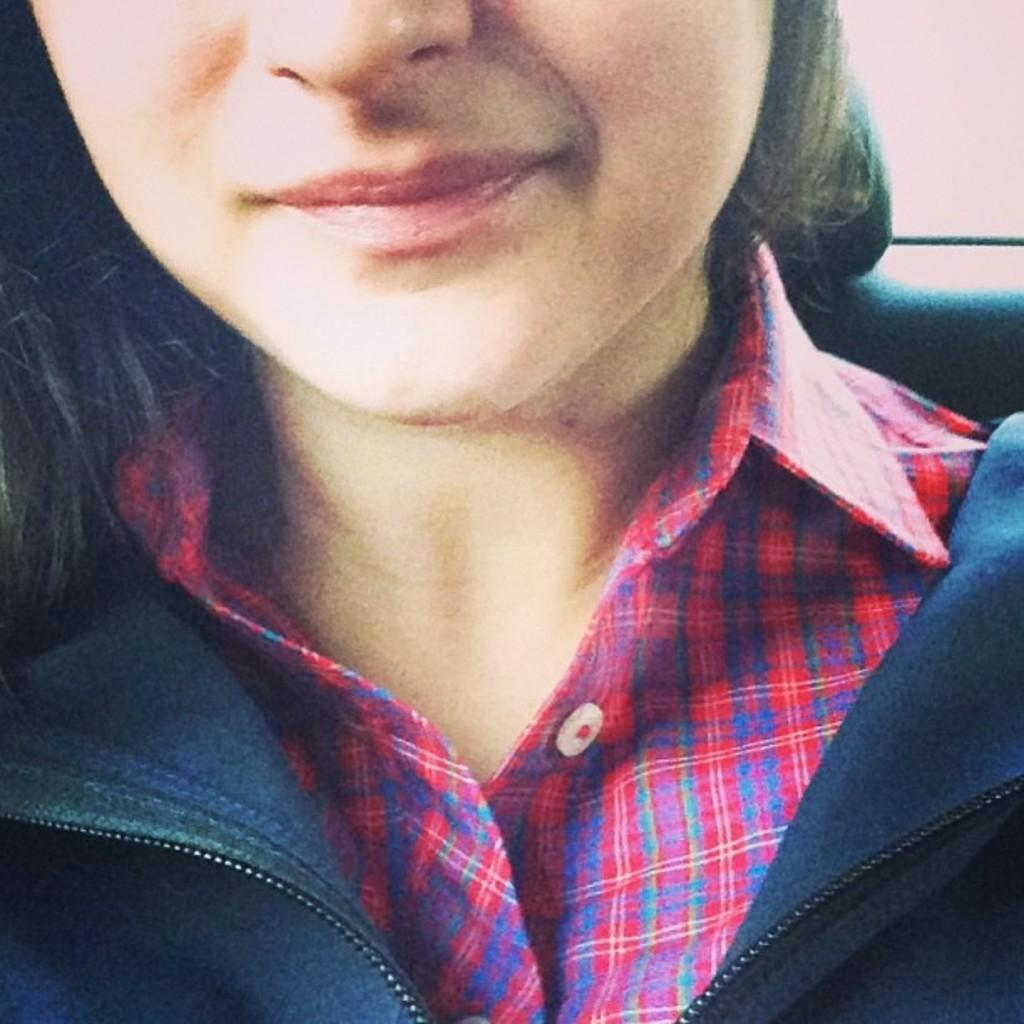Who is the main subject in the image? There is a girl in the image. What can be observed about the girl's face in the image? Only half of the girl's face is visible in the image. What color is the girl's shirt in the image? The girl is wearing a red color shirt in the image. What type of outerwear is the girl wearing in the image? The girl is wearing a blue jacket in the image. What type of flower is the girl holding in the image? There is no flower present in the image; the girl is not holding anything. What type of linen is used to make the girl's shirt in the image? The girl's shirt is not described in terms of its fabric, only its color (red). Is there a knife visible in the image? No, there is no knife present in the image. 